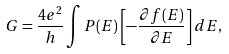Convert formula to latex. <formula><loc_0><loc_0><loc_500><loc_500>G = \frac { 4 e ^ { 2 } } { h } \int P ( E ) \left [ - \frac { \partial f ( E ) } { \partial E } \right ] d E ,</formula> 